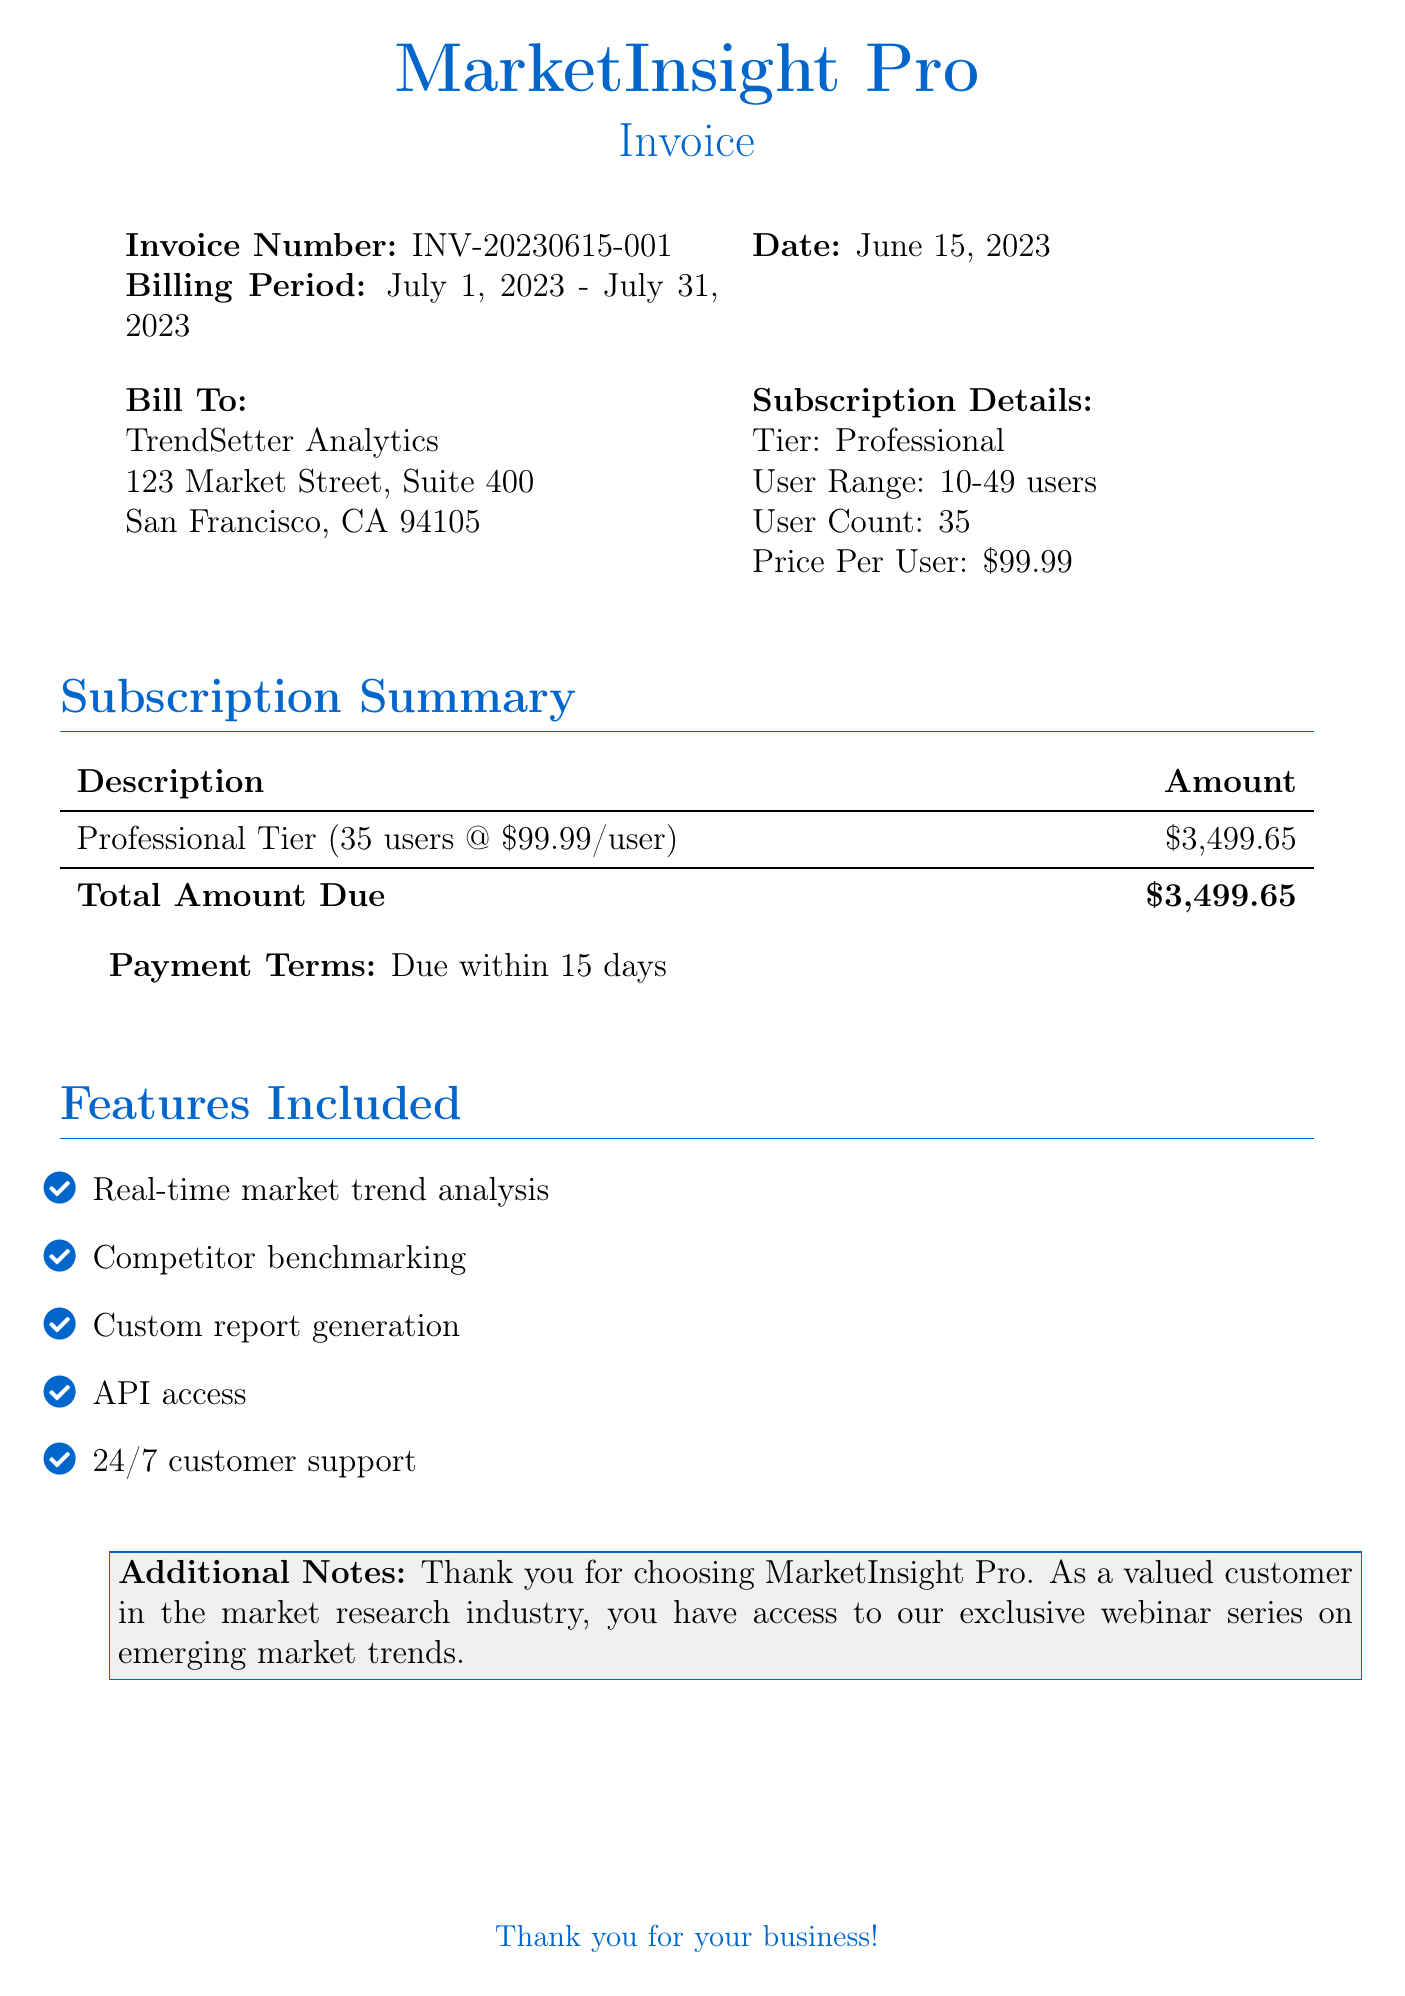What is the invoice number? The invoice number is provided in the document as a unique identifier for the invoice.
Answer: INV-20230615-001 What is the billing period? The billing period indicates the timeframe for which the subscription is billed, specifically stated in the document.
Answer: July 1, 2023 - July 31, 2023 Who is the bill to? The "Bill To" section indicates the name of the customer receiving the invoice.
Answer: TrendSetter Analytics What is the user count? The user count indicates how many users are covered under the subscription, specified in the document.
Answer: 35 What is the total amount due? The total amount due is the final amount that needs to be paid based on the subscription details.
Answer: $3,499.65 What tier is the subscription? The tier indicates the level of service the customer is subscribed to, which is stated in the subscription details.
Answer: Professional How many users does the professional tier cover? The "User Range" indicates the number of users permitted in this subscription tier.
Answer: 10-49 users What is the price per user? The price per user indicates how much each user costs under the subscription.
Answer: $99.99 When is the payment due? The payment terms specify when the payment should be completed.
Answer: Due within 15 days 